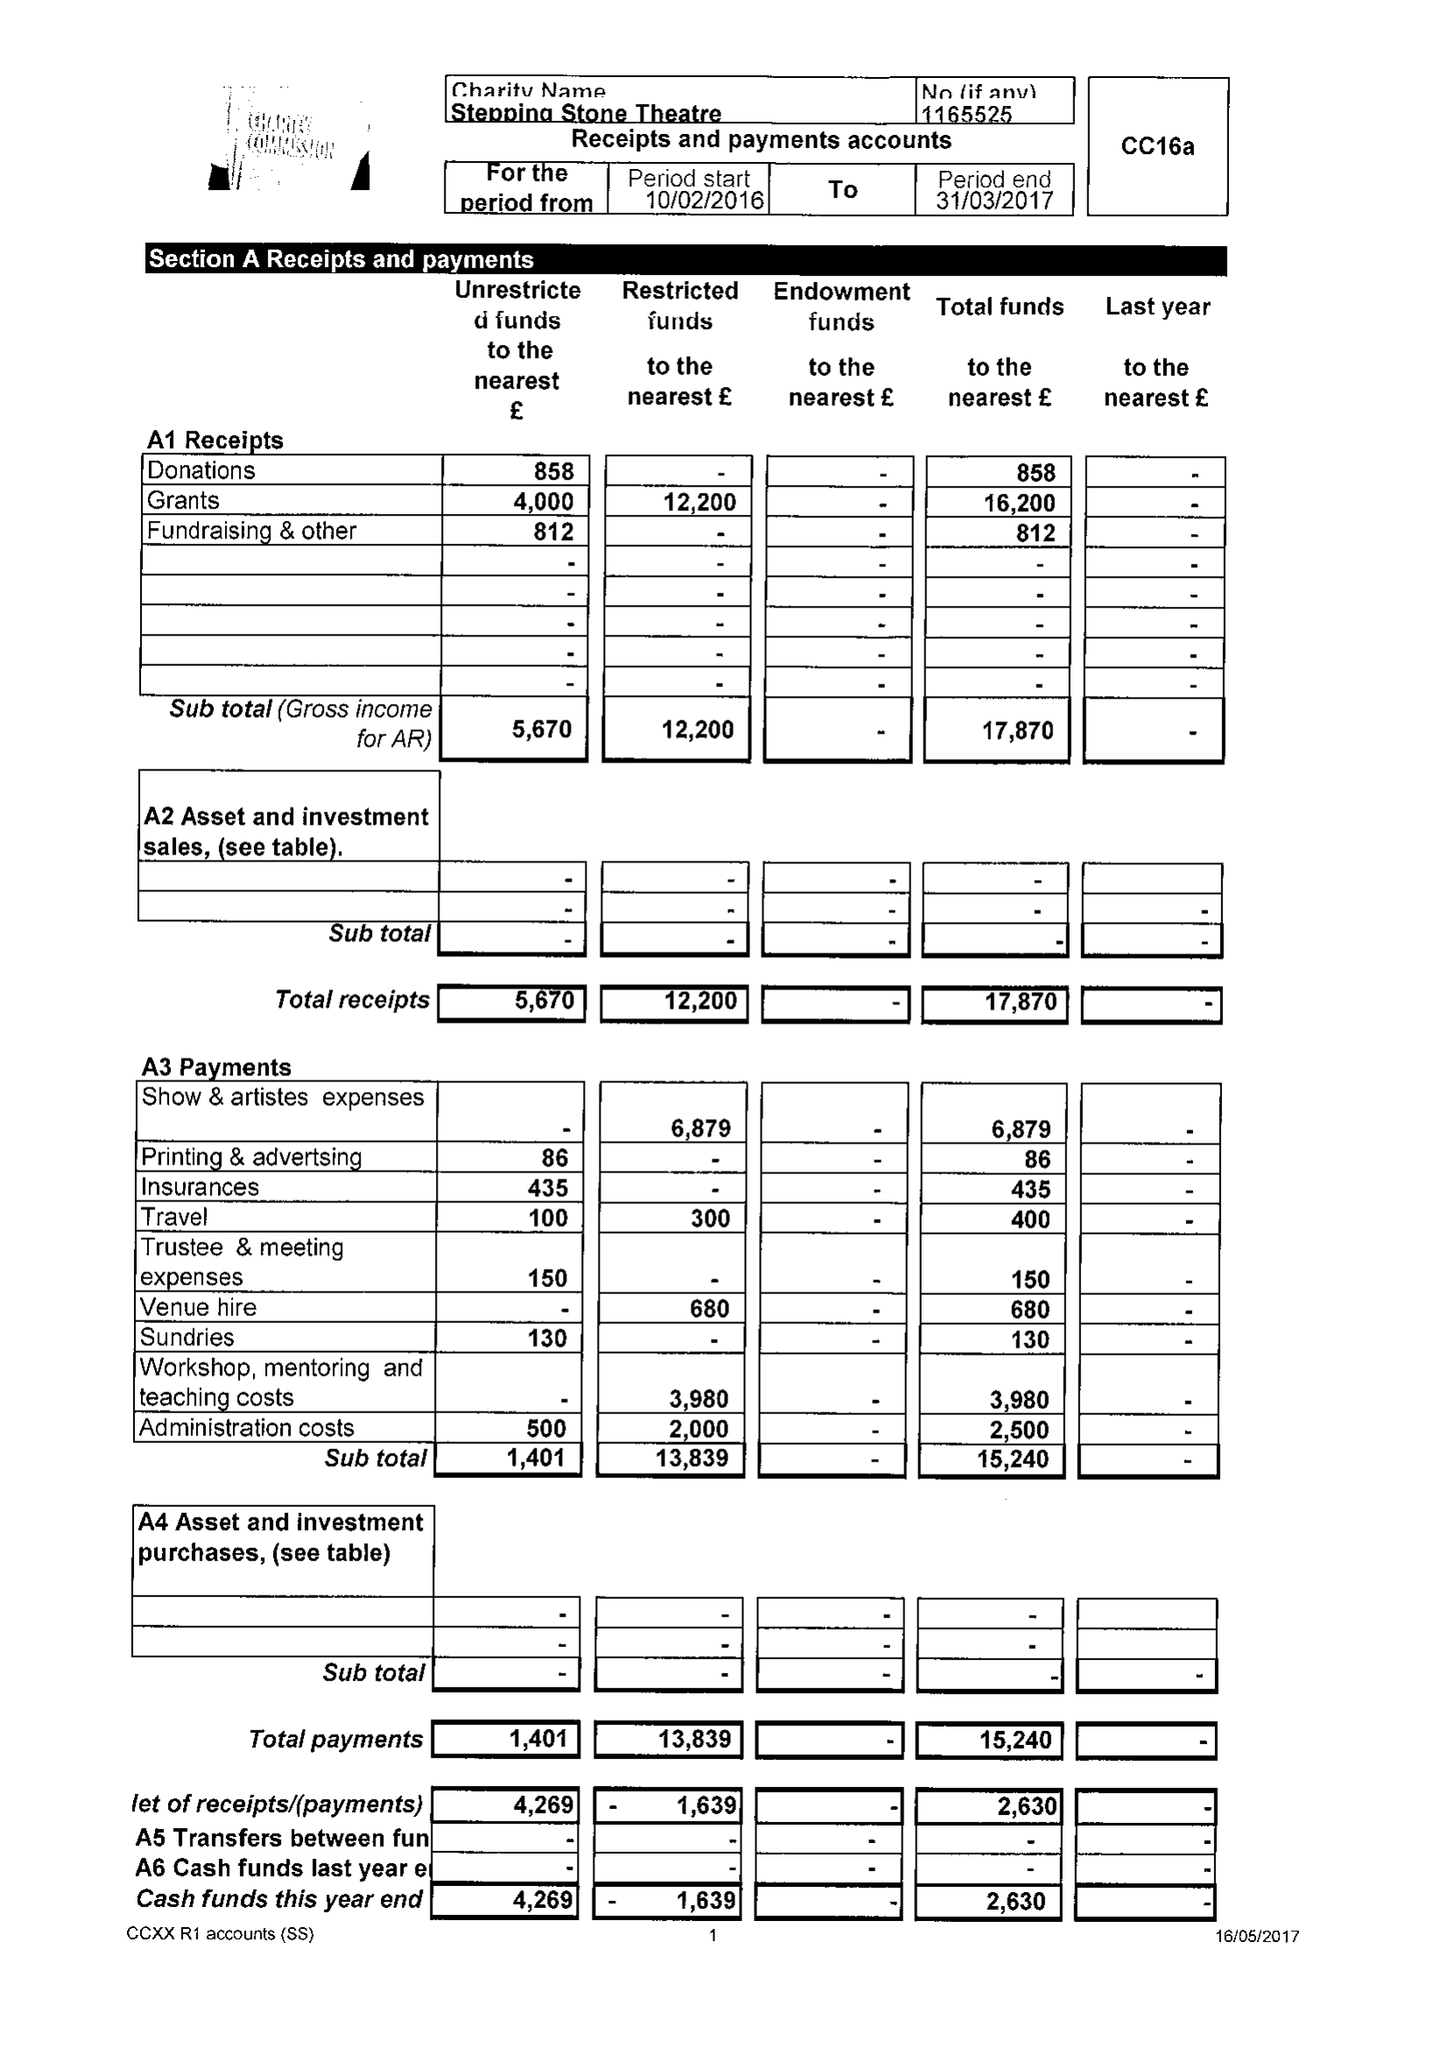What is the value for the address__postcode?
Answer the question using a single word or phrase. DN21 3JZ 